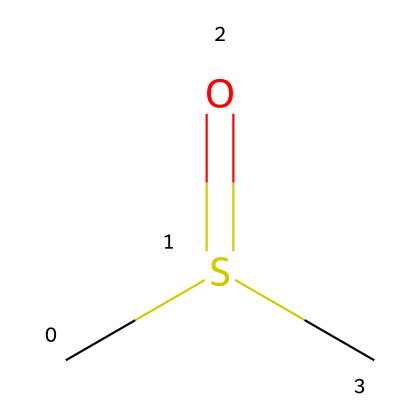What is the molecular formula of this compound? To determine the molecular formula, we need to count the number of each type of atom in the given SMILES representation. The SMILES CS(=O)C indicates that there are 2 carbon atoms (C), 6 hydrogen atoms (H), and 1 sulfur atom (S) along with an oxygen atom (O). Combining these gives the molecular formula C2H6OS.
Answer: C2H6OS How many sulfur atoms are present in this molecule? The SMILES representation shows the presence of only one sulfur atom in the structure indicated by 'S'.
Answer: 1 What type of functional group is present in dimethyl sulfoxide? The functional group is identified from the structure, specifically the carbonyl (C=O) bonded to a sulfur atom, which characterizes sulfoxides like DMSO.
Answer: sulfoxide How many hydrogen atoms are attached to each carbon atom in this compound? By analyzing the SMILES structure, each carbon (C) is fully saturated with hydrogens given the overall structure, indicating that each carbon atom is bonded to three or two hydrogen atoms depending on its connectivity. In DMSO, one carbon is bonded to three hydrogens (methyl group) and the other to two (next to sulfur).
Answer: 3 and 2 What is the total number of atoms in dimethyl sulfoxide? The total number of atoms is calculated by adding the number of each type of atom from the molecular formula: 2 carbon (C), 6 hydrogen (H), 1 sulfur (S), and 1 oxygen (O). Thus, total atoms = 2 + 6 + 1 + 1 = 10.
Answer: 10 Is this compound polar or nonpolar? The presence of the polar sulfoxide functional group contributes to the overall polarity of the molecule, despite the presence of the nonpolar methyl groups; the molecule is polar because of the sulfur and oxygen atoms’ electronegativity differences.
Answer: polar Why is dimethyl sulfoxide considered a good solvent? Dimethyl sulfoxide's capability to dissolve both polar and nonpolar substances can be attributed to its dipole moment from the polar sulfoxide functional group, allowing it to interact with a wide range of molecules; this makes it versatile in various applications.
Answer: versatile solvent 